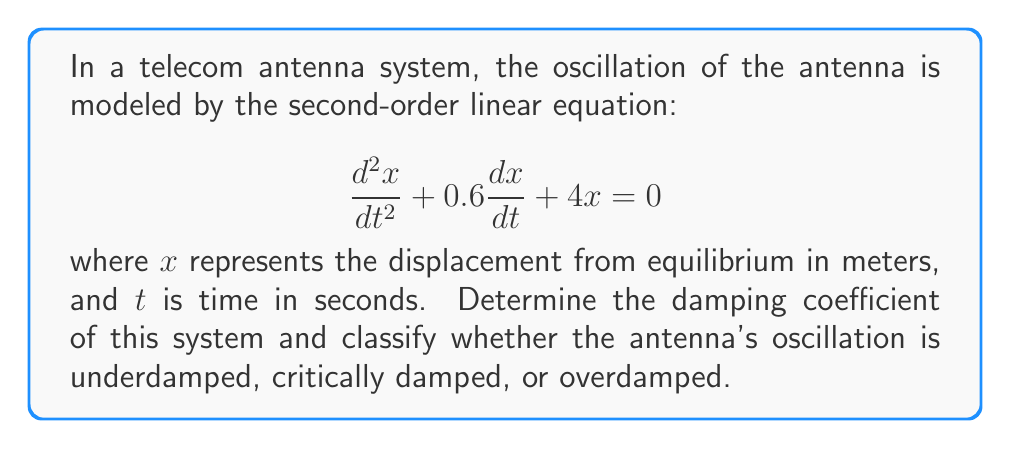Could you help me with this problem? To solve this problem, we need to follow these steps:

1) The general form of a second-order linear equation is:

   $$\frac{d^2x}{dt^2} + 2\zeta\omega_n\frac{dx}{dt} + \omega_n^2x = 0$$

   where $\zeta$ is the damping ratio and $\omega_n$ is the natural frequency.

2) Comparing our equation to the general form:

   $$\frac{d^2x}{dt^2} + 0.6\frac{dx}{dt} + 4x = 0$$

   We can see that $2\zeta\omega_n = 0.6$ and $\omega_n^2 = 4$

3) From $\omega_n^2 = 4$, we can determine $\omega_n$:

   $$\omega_n = \sqrt{4} = 2 \text{ rad/s}$$

4) Now we can find $\zeta$:

   $$2\zeta\omega_n = 0.6$$
   $$2\zeta(2) = 0.6$$
   $$\zeta = \frac{0.6}{4} = 0.15$$

5) The damping coefficient, typically denoted as $c$, is related to $\zeta$ by:

   $$c = 2\zeta\omega_n m$$

   where $m$ is the mass. In this case, we don't have a mass given, so we'll leave it as $m$.

6) Substituting our values:

   $$c = 2(0.15)(2)m = 0.6m \text{ N⋅s/m}$$

7) To classify the oscillation:
   - If $\zeta < 1$, the system is underdamped
   - If $\zeta = 1$, the system is critically damped
   - If $\zeta > 1$, the system is overdamped

   Since $\zeta = 0.15 < 1$, the system is underdamped.
Answer: The damping coefficient is $0.6m \text{ N⋅s/m}$, where $m$ is the mass of the system. The antenna's oscillation is underdamped as the damping ratio $\zeta = 0.15 < 1$. 